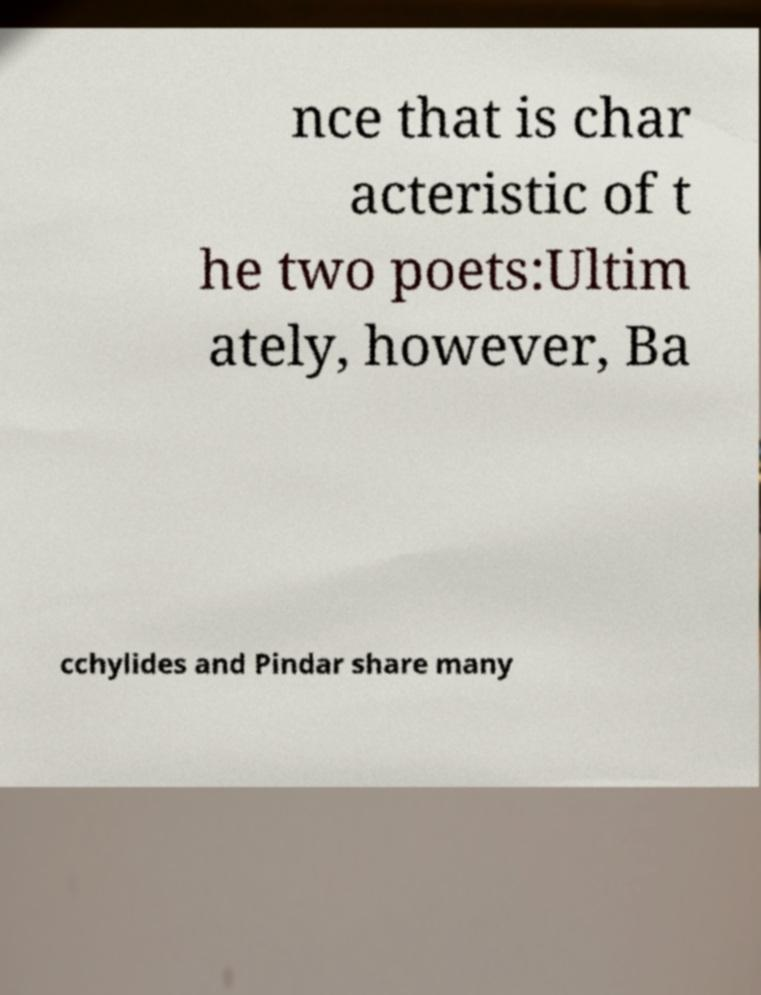There's text embedded in this image that I need extracted. Can you transcribe it verbatim? nce that is char acteristic of t he two poets:Ultim ately, however, Ba cchylides and Pindar share many 